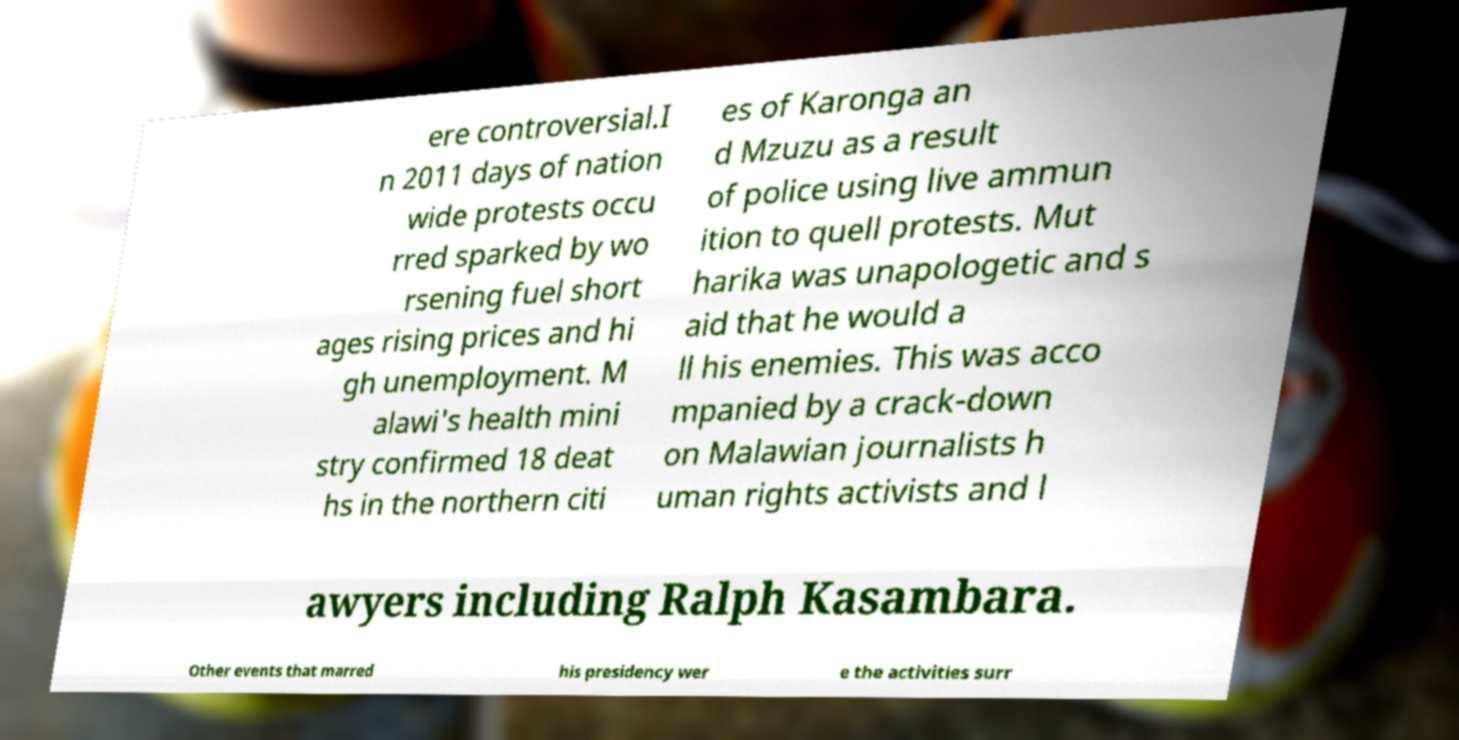Could you extract and type out the text from this image? ere controversial.I n 2011 days of nation wide protests occu rred sparked by wo rsening fuel short ages rising prices and hi gh unemployment. M alawi's health mini stry confirmed 18 deat hs in the northern citi es of Karonga an d Mzuzu as a result of police using live ammun ition to quell protests. Mut harika was unapologetic and s aid that he would a ll his enemies. This was acco mpanied by a crack-down on Malawian journalists h uman rights activists and l awyers including Ralph Kasambara. Other events that marred his presidency wer e the activities surr 